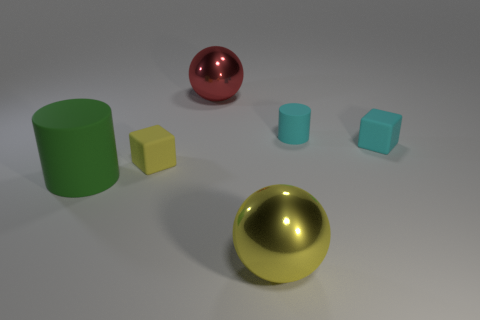Subtract all red cubes. Subtract all purple cylinders. How many cubes are left? 2 Add 1 big yellow balls. How many objects exist? 7 Subtract all balls. How many objects are left? 4 Subtract all big blue shiny cylinders. Subtract all cylinders. How many objects are left? 4 Add 5 big red shiny things. How many big red shiny things are left? 6 Add 1 tiny cubes. How many tiny cubes exist? 3 Subtract 0 red cylinders. How many objects are left? 6 